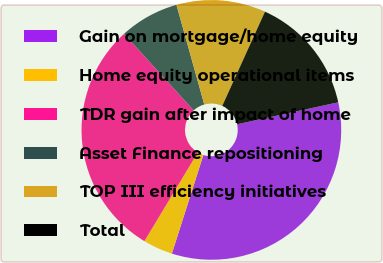<chart> <loc_0><loc_0><loc_500><loc_500><pie_chart><fcel>Gain on mortgage/home equity<fcel>Home equity operational items<fcel>TDR gain after impact of home<fcel>Asset Finance repositioning<fcel>TOP III efficiency initiatives<fcel>Total<nl><fcel>33.33%<fcel>3.7%<fcel>29.63%<fcel>7.41%<fcel>11.11%<fcel>14.81%<nl></chart> 